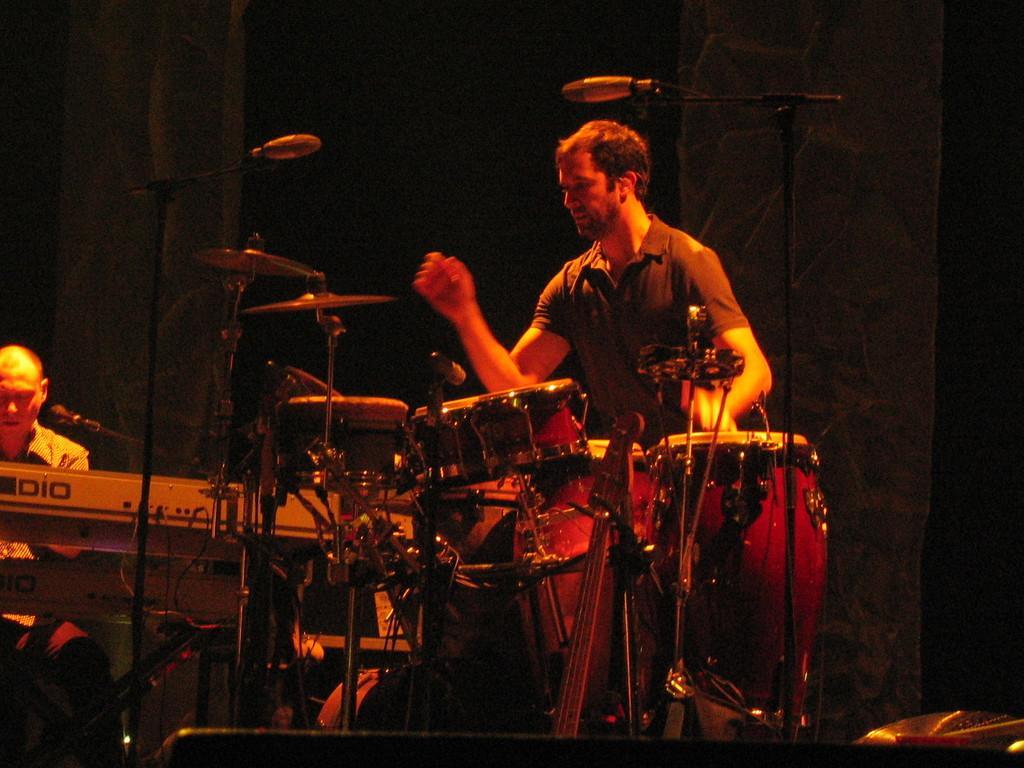Please provide a concise description of this image. In this image I can see two people and these people are playing the musical instruments. 